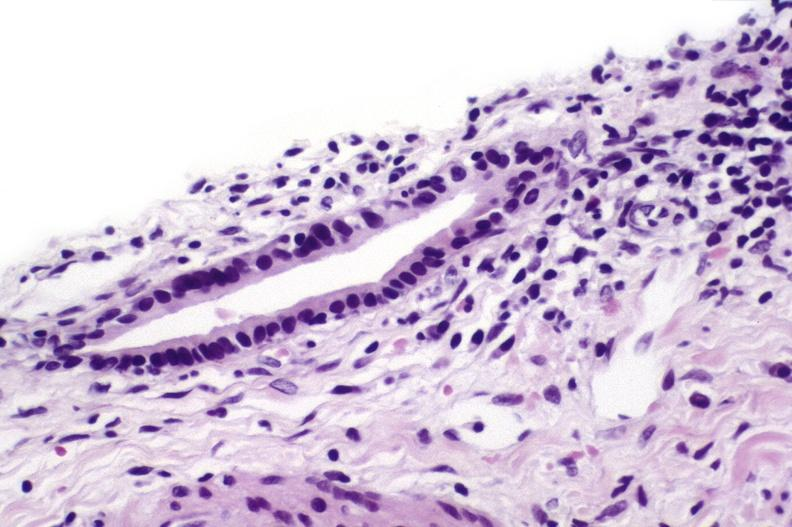s liver present?
Answer the question using a single word or phrase. Yes 